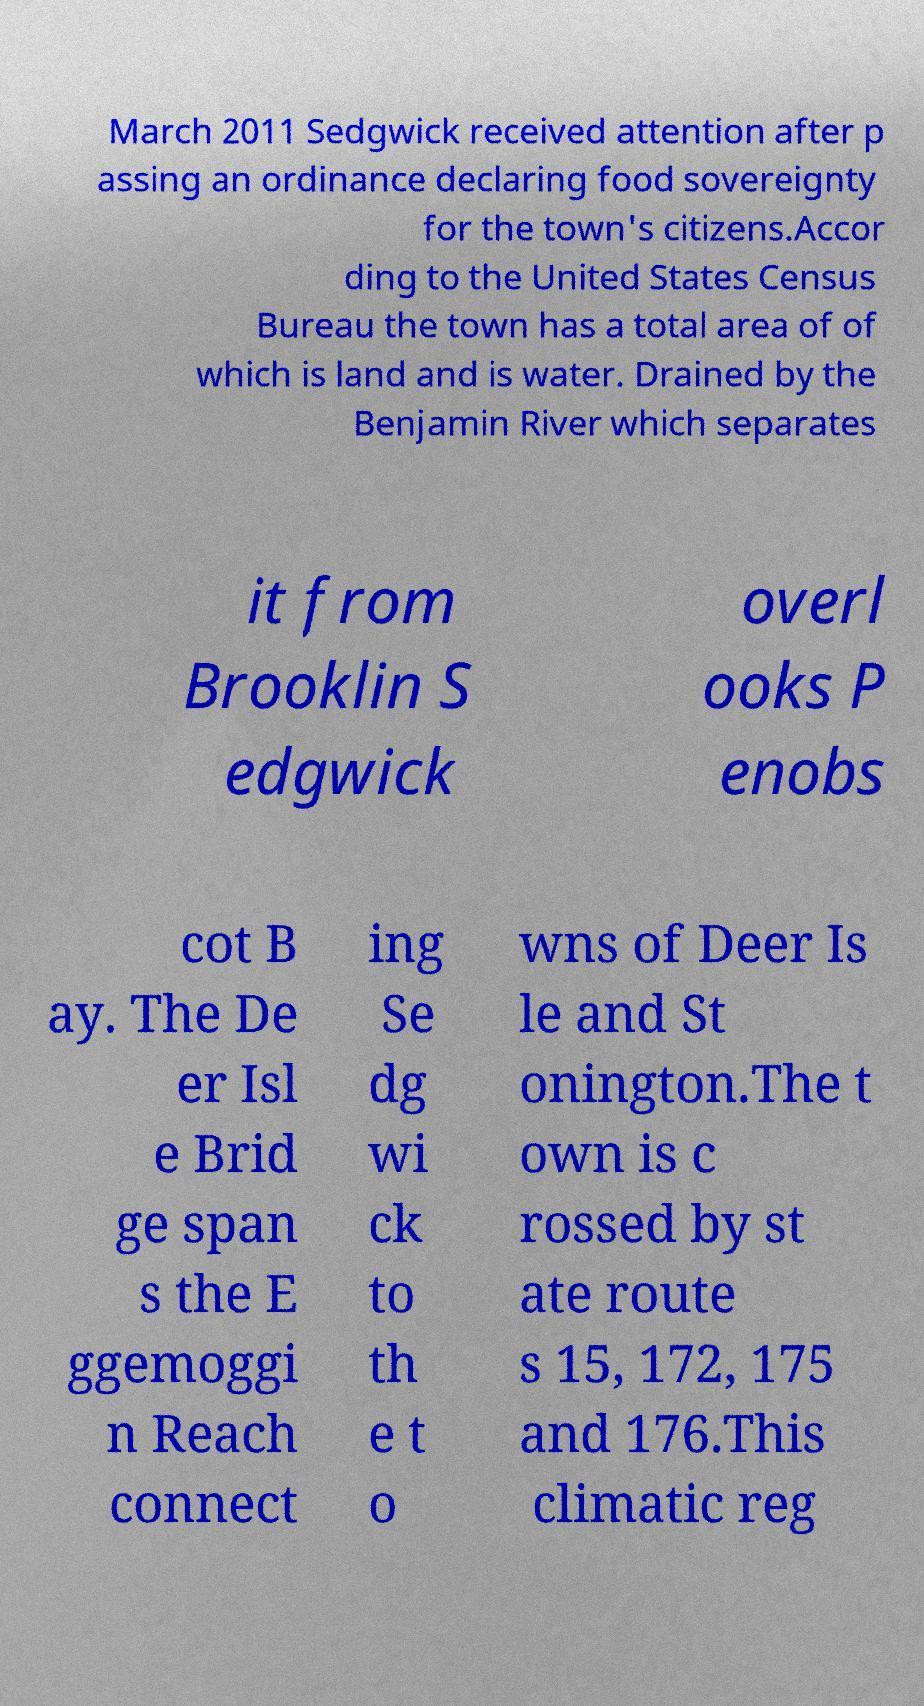Could you assist in decoding the text presented in this image and type it out clearly? March 2011 Sedgwick received attention after p assing an ordinance declaring food sovereignty for the town's citizens.Accor ding to the United States Census Bureau the town has a total area of of which is land and is water. Drained by the Benjamin River which separates it from Brooklin S edgwick overl ooks P enobs cot B ay. The De er Isl e Brid ge span s the E ggemoggi n Reach connect ing Se dg wi ck to th e t o wns of Deer Is le and St onington.The t own is c rossed by st ate route s 15, 172, 175 and 176.This climatic reg 